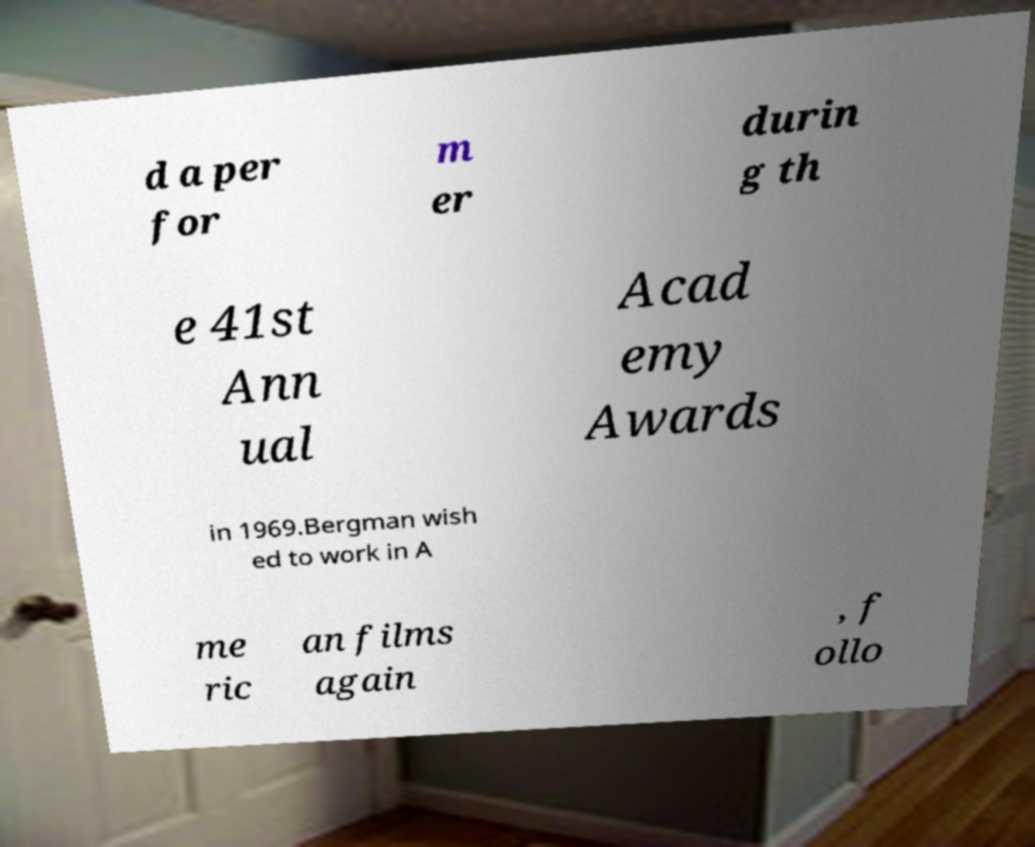What messages or text are displayed in this image? I need them in a readable, typed format. d a per for m er durin g th e 41st Ann ual Acad emy Awards in 1969.Bergman wish ed to work in A me ric an films again , f ollo 